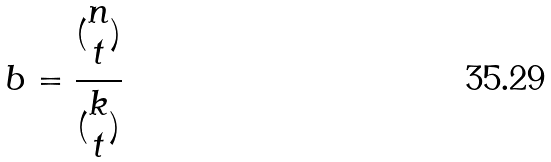Convert formula to latex. <formula><loc_0><loc_0><loc_500><loc_500>b = \frac { ( \begin{matrix} n \\ t \end{matrix} ) } { ( \begin{matrix} k \\ t \end{matrix} ) }</formula> 